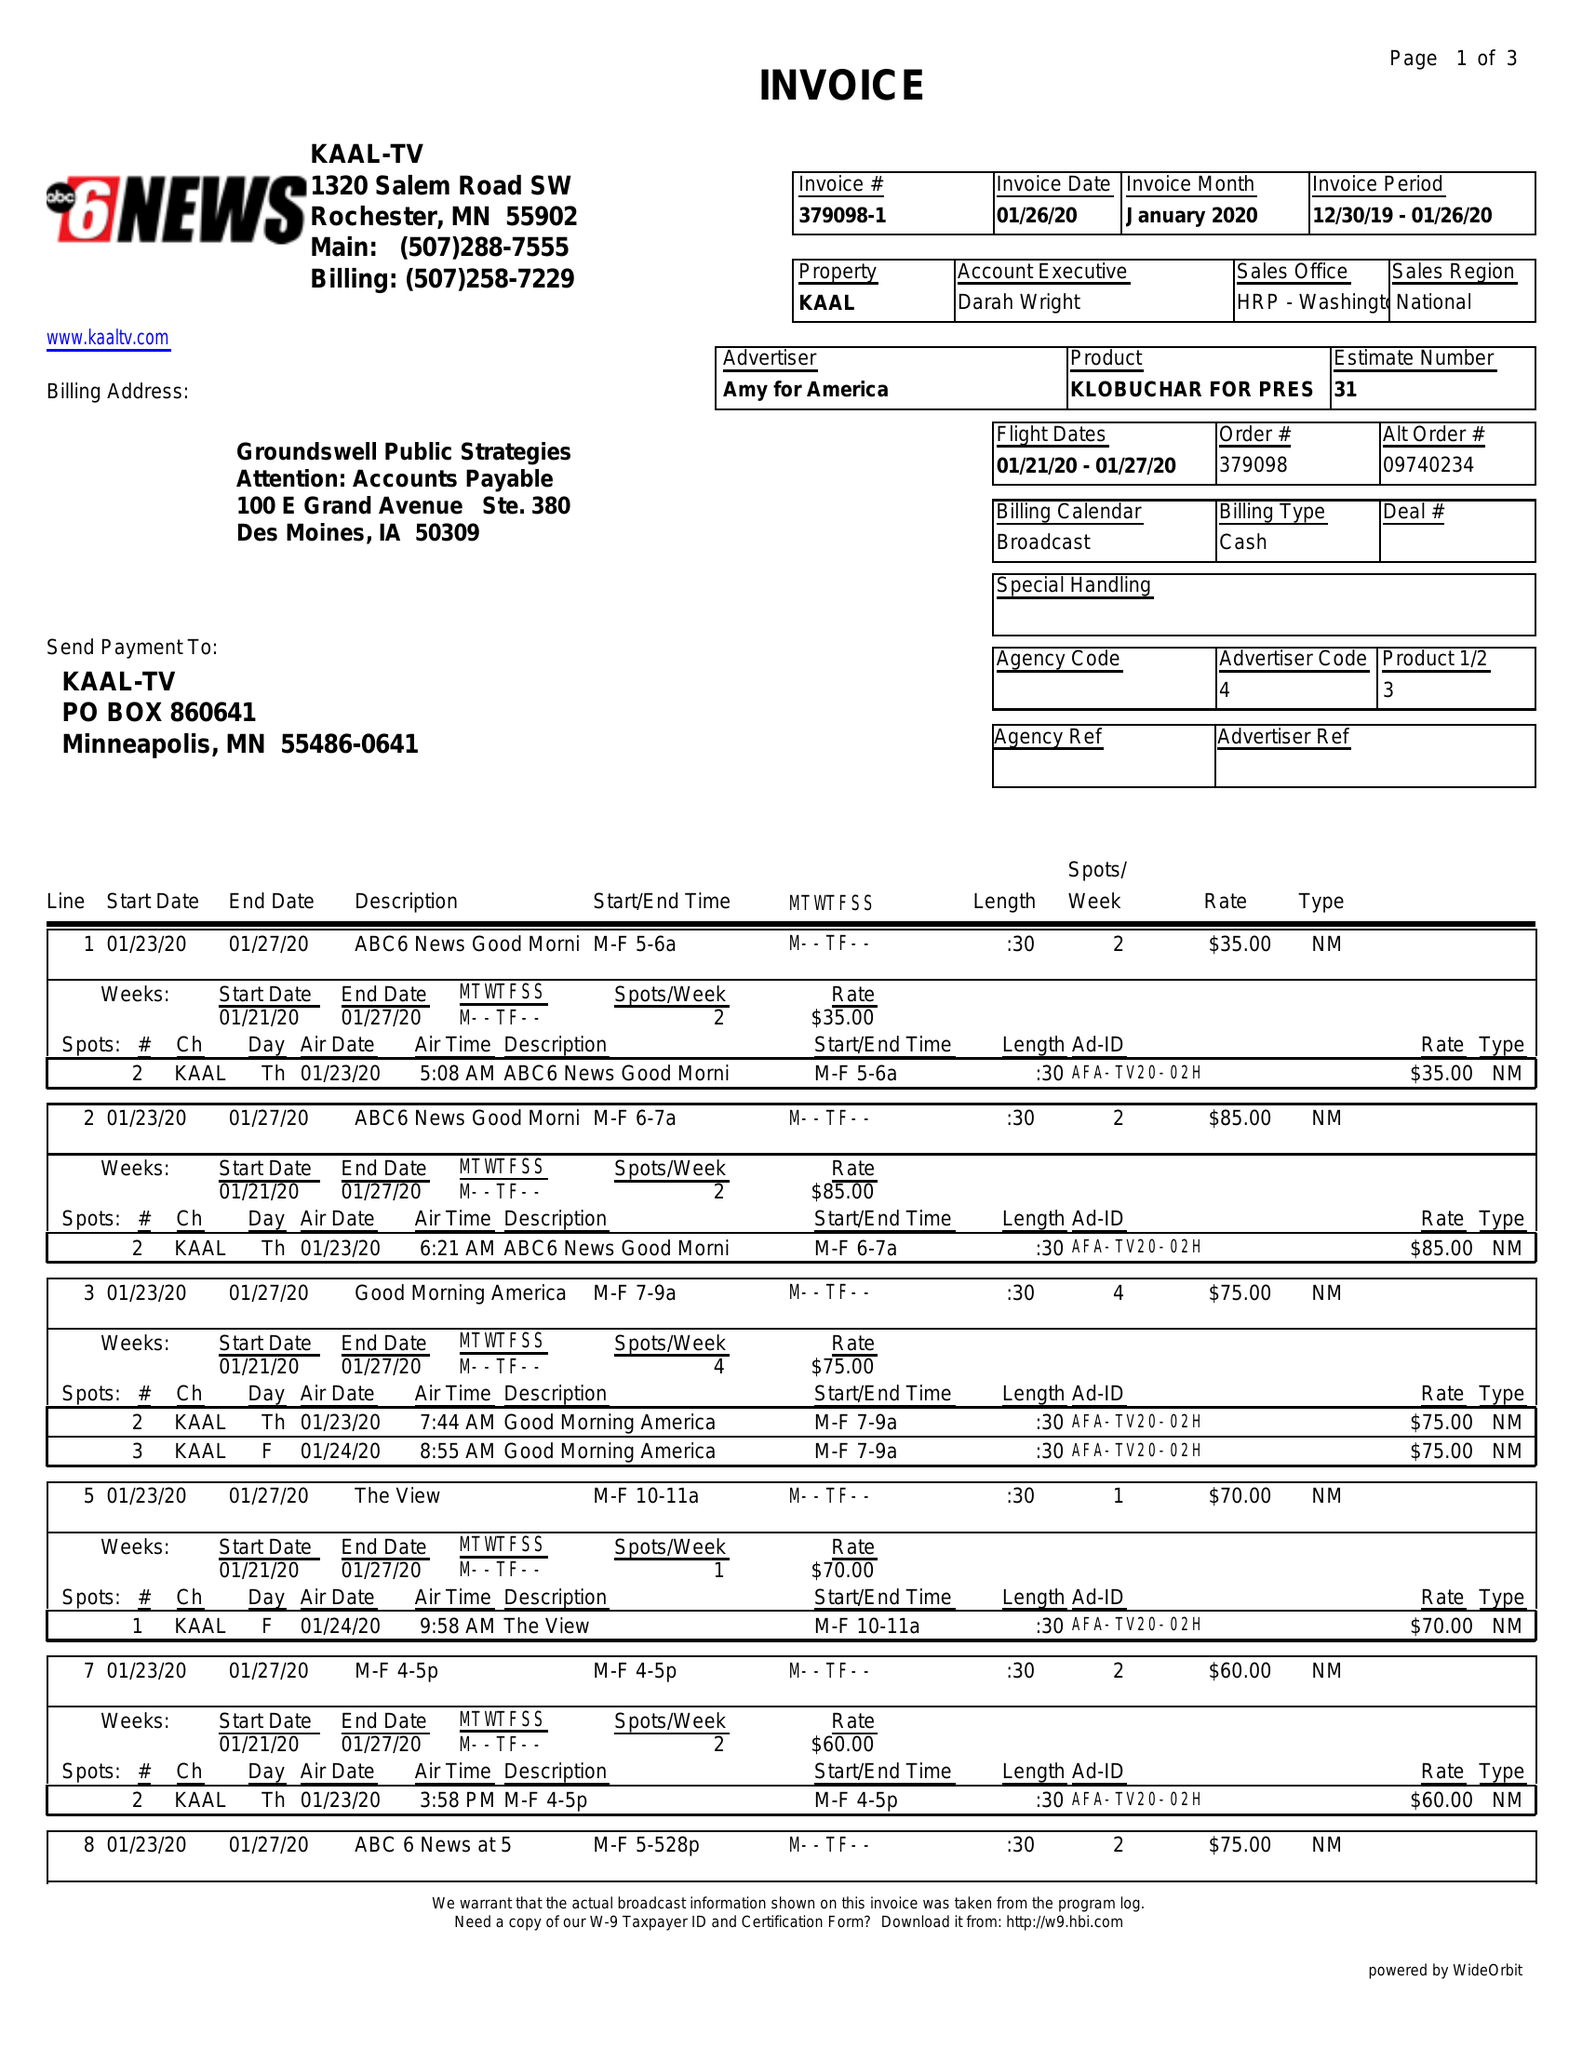What is the value for the flight_to?
Answer the question using a single word or phrase. 01/27/20 